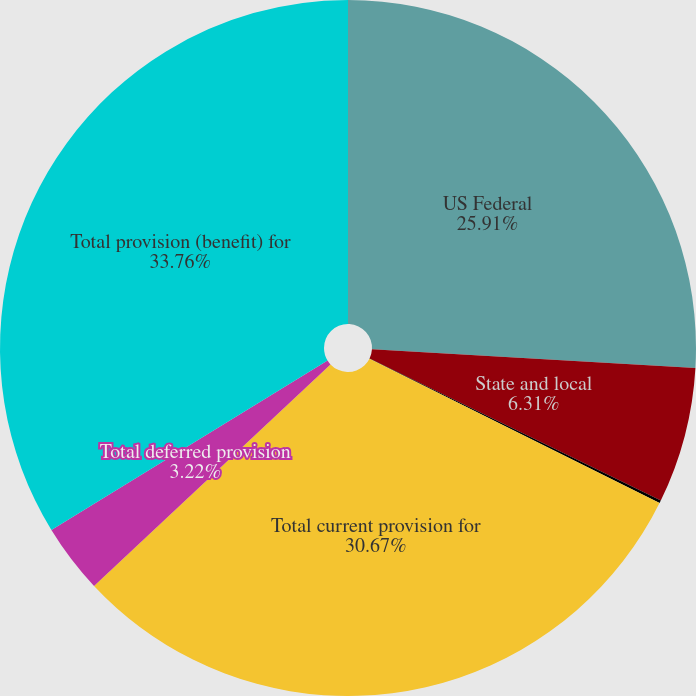Convert chart to OTSL. <chart><loc_0><loc_0><loc_500><loc_500><pie_chart><fcel>US Federal<fcel>State and local<fcel>Foreign<fcel>Total current provision for<fcel>Total deferred provision<fcel>Total provision (benefit) for<nl><fcel>25.91%<fcel>6.31%<fcel>0.13%<fcel>30.67%<fcel>3.22%<fcel>33.76%<nl></chart> 